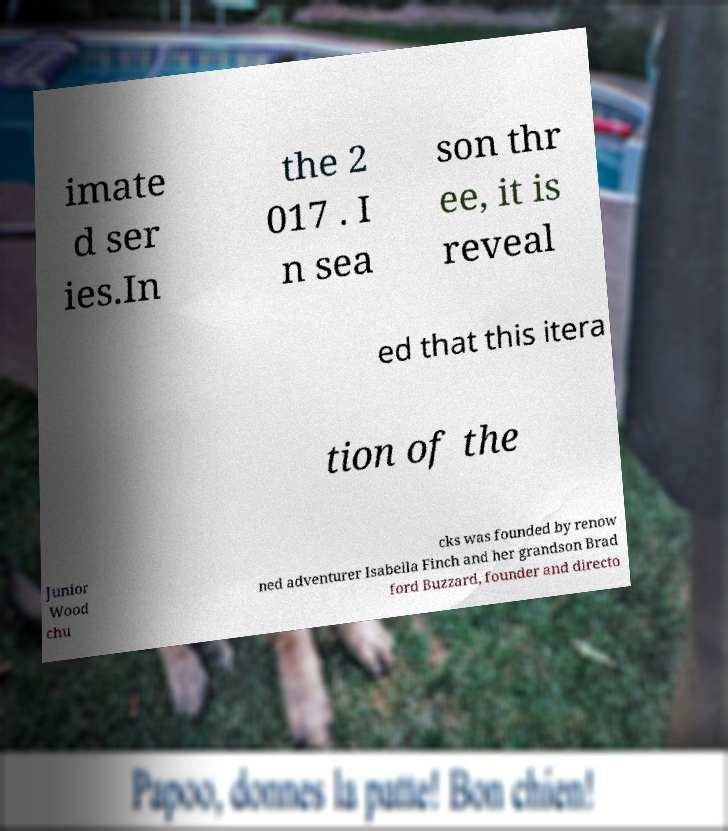What messages or text are displayed in this image? I need them in a readable, typed format. imate d ser ies.In the 2 017 . I n sea son thr ee, it is reveal ed that this itera tion of the Junior Wood chu cks was founded by renow ned adventurer Isabella Finch and her grandson Brad ford Buzzard, founder and directo 